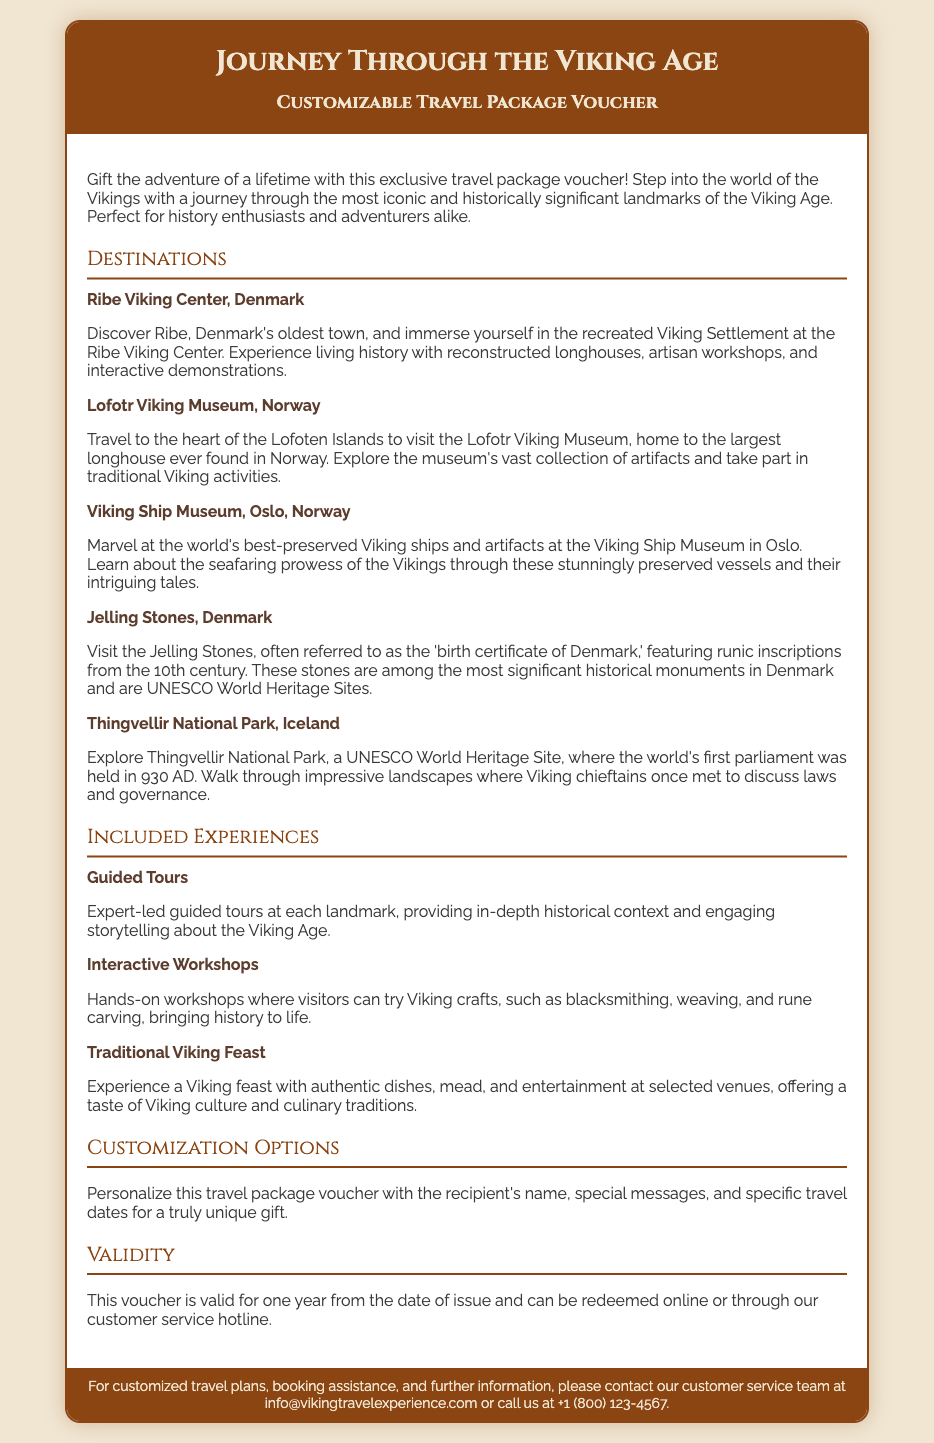What is the title of the voucher? The title of the voucher is found in the header section, stated clearly as “Journey Through the Viking Age.”
Answer: Journey Through the Viking Age How long is the voucher valid? The validity of the voucher is mentioned in the section titled "Validity," which states it is valid for one year from the date of issue.
Answer: One year What is one included experience in the voucher? One included experience can be found in the "Included Experiences" section, where multiple activities are listed. Examples are guided tours, workshops, and feasts.
Answer: Guided Tours Which landmark features the largest longhouse? The landmark known for having the largest longhouse is specified in the "Destinations" section of the document.
Answer: Lofotr Viking Museum, Norway What is a customization option for this voucher? The customization options are explained in the "Customization Options" section, where personalization with the recipient's name and special messages is mentioned.
Answer: Recipient's name What are the Jelling Stones known as? The Jelling Stones are referred to in the "Destinations" section, describing them as the "birth certificate of Denmark."
Answer: Birth certificate of Denmark Which country is the Ribe Viking Center located in? The location of the Ribe Viking Center is indicated in the "Destinations" section, where it states it is found in Denmark.
Answer: Denmark What type of tours are included in the experiences? The document specifies the type of tours in the "Included Experiences" section, which are described as expert-led guided tours.
Answer: Guided Tours 